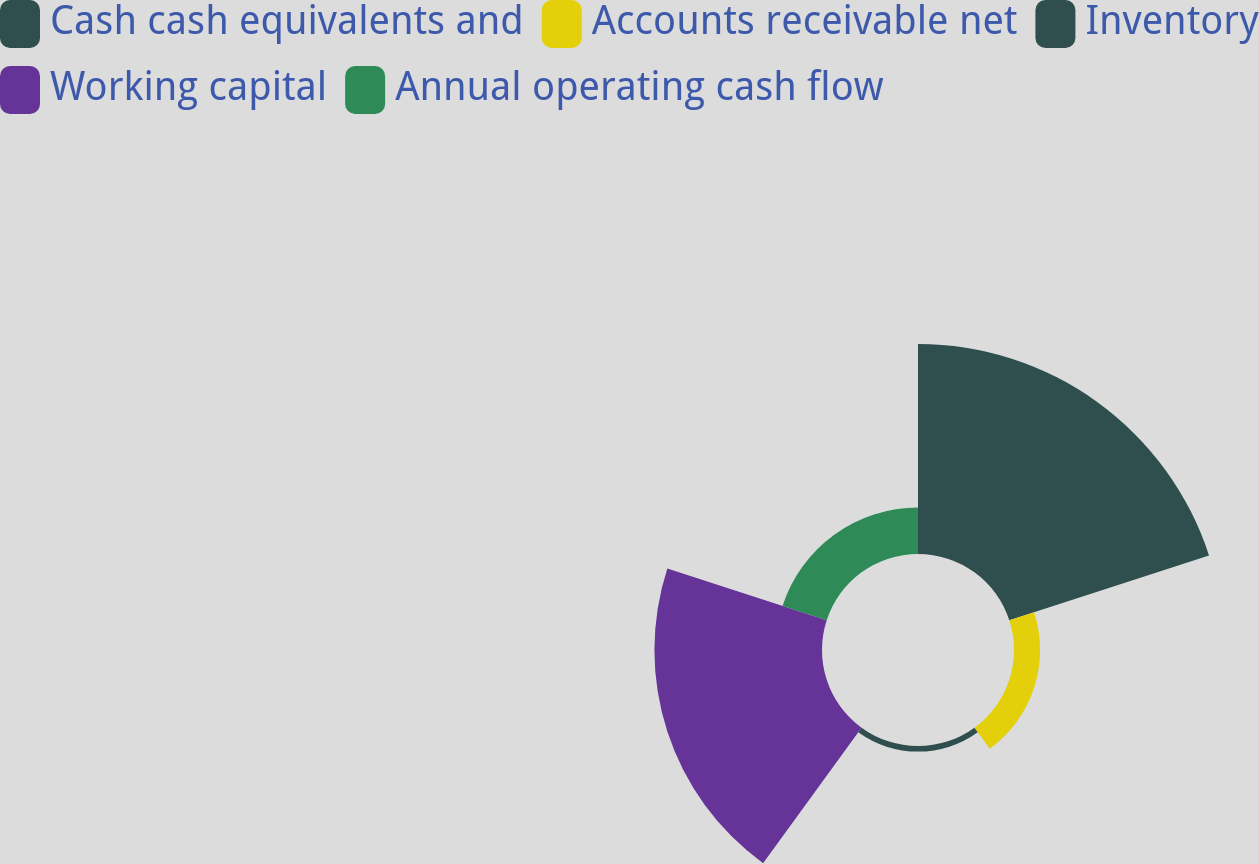Convert chart to OTSL. <chart><loc_0><loc_0><loc_500><loc_500><pie_chart><fcel>Cash cash equivalents and<fcel>Accounts receivable net<fcel>Inventory<fcel>Working capital<fcel>Annual operating cash flow<nl><fcel>46.08%<fcel>5.72%<fcel>1.23%<fcel>36.77%<fcel>10.2%<nl></chart> 